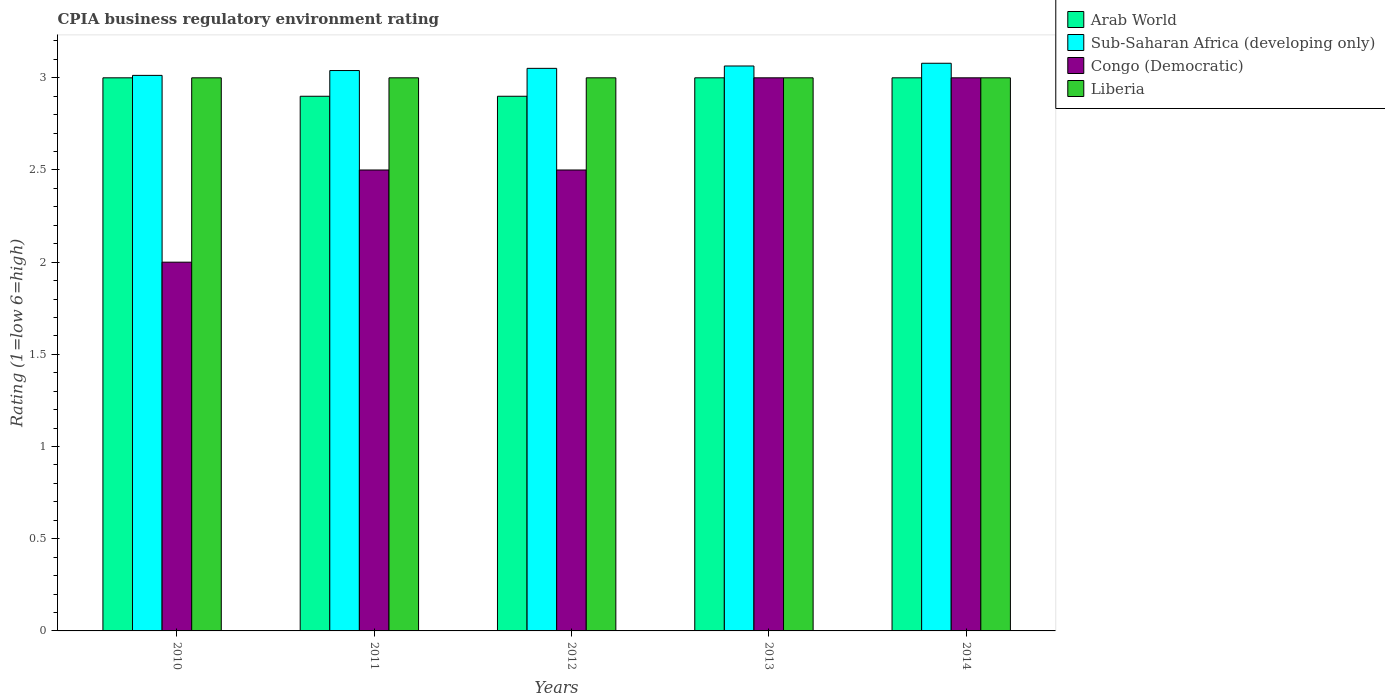How many different coloured bars are there?
Provide a short and direct response. 4. How many groups of bars are there?
Give a very brief answer. 5. What is the label of the 2nd group of bars from the left?
Offer a terse response. 2011. What is the CPIA rating in Sub-Saharan Africa (developing only) in 2010?
Your answer should be compact. 3.01. Across all years, what is the maximum CPIA rating in Liberia?
Keep it short and to the point. 3. In which year was the CPIA rating in Arab World maximum?
Offer a terse response. 2010. What is the average CPIA rating in Arab World per year?
Offer a terse response. 2.96. In the year 2014, what is the difference between the CPIA rating in Arab World and CPIA rating in Sub-Saharan Africa (developing only)?
Your response must be concise. -0.08. What is the difference between the highest and the second highest CPIA rating in Sub-Saharan Africa (developing only)?
Offer a very short reply. 0.01. What is the difference between the highest and the lowest CPIA rating in Sub-Saharan Africa (developing only)?
Make the answer very short. 0.07. In how many years, is the CPIA rating in Sub-Saharan Africa (developing only) greater than the average CPIA rating in Sub-Saharan Africa (developing only) taken over all years?
Keep it short and to the point. 3. Is the sum of the CPIA rating in Liberia in 2010 and 2011 greater than the maximum CPIA rating in Congo (Democratic) across all years?
Provide a succinct answer. Yes. What does the 2nd bar from the left in 2014 represents?
Your answer should be compact. Sub-Saharan Africa (developing only). What does the 4th bar from the right in 2011 represents?
Give a very brief answer. Arab World. Are all the bars in the graph horizontal?
Keep it short and to the point. No. How many years are there in the graph?
Your answer should be compact. 5. What is the difference between two consecutive major ticks on the Y-axis?
Keep it short and to the point. 0.5. Are the values on the major ticks of Y-axis written in scientific E-notation?
Provide a succinct answer. No. Where does the legend appear in the graph?
Provide a succinct answer. Top right. What is the title of the graph?
Your response must be concise. CPIA business regulatory environment rating. Does "Botswana" appear as one of the legend labels in the graph?
Your answer should be very brief. No. What is the label or title of the Y-axis?
Offer a very short reply. Rating (1=low 6=high). What is the Rating (1=low 6=high) of Arab World in 2010?
Ensure brevity in your answer.  3. What is the Rating (1=low 6=high) in Sub-Saharan Africa (developing only) in 2010?
Provide a short and direct response. 3.01. What is the Rating (1=low 6=high) of Liberia in 2010?
Provide a short and direct response. 3. What is the Rating (1=low 6=high) in Sub-Saharan Africa (developing only) in 2011?
Give a very brief answer. 3.04. What is the Rating (1=low 6=high) in Sub-Saharan Africa (developing only) in 2012?
Your answer should be very brief. 3.05. What is the Rating (1=low 6=high) in Congo (Democratic) in 2012?
Give a very brief answer. 2.5. What is the Rating (1=low 6=high) in Arab World in 2013?
Offer a terse response. 3. What is the Rating (1=low 6=high) of Sub-Saharan Africa (developing only) in 2013?
Offer a terse response. 3.06. What is the Rating (1=low 6=high) in Congo (Democratic) in 2013?
Keep it short and to the point. 3. What is the Rating (1=low 6=high) of Liberia in 2013?
Your answer should be compact. 3. What is the Rating (1=low 6=high) in Arab World in 2014?
Your answer should be very brief. 3. What is the Rating (1=low 6=high) in Sub-Saharan Africa (developing only) in 2014?
Your answer should be compact. 3.08. What is the Rating (1=low 6=high) in Liberia in 2014?
Your response must be concise. 3. Across all years, what is the maximum Rating (1=low 6=high) of Sub-Saharan Africa (developing only)?
Provide a succinct answer. 3.08. Across all years, what is the maximum Rating (1=low 6=high) of Congo (Democratic)?
Provide a succinct answer. 3. Across all years, what is the maximum Rating (1=low 6=high) of Liberia?
Keep it short and to the point. 3. Across all years, what is the minimum Rating (1=low 6=high) in Arab World?
Provide a succinct answer. 2.9. Across all years, what is the minimum Rating (1=low 6=high) of Sub-Saharan Africa (developing only)?
Provide a short and direct response. 3.01. Across all years, what is the minimum Rating (1=low 6=high) of Congo (Democratic)?
Give a very brief answer. 2. Across all years, what is the minimum Rating (1=low 6=high) of Liberia?
Keep it short and to the point. 3. What is the total Rating (1=low 6=high) of Arab World in the graph?
Offer a terse response. 14.8. What is the total Rating (1=low 6=high) in Sub-Saharan Africa (developing only) in the graph?
Ensure brevity in your answer.  15.25. What is the difference between the Rating (1=low 6=high) of Sub-Saharan Africa (developing only) in 2010 and that in 2011?
Your answer should be compact. -0.03. What is the difference between the Rating (1=low 6=high) of Liberia in 2010 and that in 2011?
Make the answer very short. 0. What is the difference between the Rating (1=low 6=high) of Arab World in 2010 and that in 2012?
Offer a very short reply. 0.1. What is the difference between the Rating (1=low 6=high) in Sub-Saharan Africa (developing only) in 2010 and that in 2012?
Keep it short and to the point. -0.04. What is the difference between the Rating (1=low 6=high) in Liberia in 2010 and that in 2012?
Ensure brevity in your answer.  0. What is the difference between the Rating (1=low 6=high) of Arab World in 2010 and that in 2013?
Offer a very short reply. 0. What is the difference between the Rating (1=low 6=high) in Sub-Saharan Africa (developing only) in 2010 and that in 2013?
Ensure brevity in your answer.  -0.05. What is the difference between the Rating (1=low 6=high) of Congo (Democratic) in 2010 and that in 2013?
Your response must be concise. -1. What is the difference between the Rating (1=low 6=high) of Liberia in 2010 and that in 2013?
Offer a terse response. 0. What is the difference between the Rating (1=low 6=high) in Arab World in 2010 and that in 2014?
Make the answer very short. 0. What is the difference between the Rating (1=low 6=high) in Sub-Saharan Africa (developing only) in 2010 and that in 2014?
Make the answer very short. -0.07. What is the difference between the Rating (1=low 6=high) in Liberia in 2010 and that in 2014?
Ensure brevity in your answer.  0. What is the difference between the Rating (1=low 6=high) of Sub-Saharan Africa (developing only) in 2011 and that in 2012?
Make the answer very short. -0.01. What is the difference between the Rating (1=low 6=high) of Congo (Democratic) in 2011 and that in 2012?
Your answer should be very brief. 0. What is the difference between the Rating (1=low 6=high) of Arab World in 2011 and that in 2013?
Provide a short and direct response. -0.1. What is the difference between the Rating (1=low 6=high) in Sub-Saharan Africa (developing only) in 2011 and that in 2013?
Your answer should be compact. -0.02. What is the difference between the Rating (1=low 6=high) in Arab World in 2011 and that in 2014?
Keep it short and to the point. -0.1. What is the difference between the Rating (1=low 6=high) in Sub-Saharan Africa (developing only) in 2011 and that in 2014?
Offer a very short reply. -0.04. What is the difference between the Rating (1=low 6=high) in Liberia in 2011 and that in 2014?
Make the answer very short. 0. What is the difference between the Rating (1=low 6=high) of Arab World in 2012 and that in 2013?
Your answer should be compact. -0.1. What is the difference between the Rating (1=low 6=high) of Sub-Saharan Africa (developing only) in 2012 and that in 2013?
Provide a succinct answer. -0.01. What is the difference between the Rating (1=low 6=high) of Liberia in 2012 and that in 2013?
Your answer should be compact. 0. What is the difference between the Rating (1=low 6=high) in Sub-Saharan Africa (developing only) in 2012 and that in 2014?
Give a very brief answer. -0.03. What is the difference between the Rating (1=low 6=high) in Liberia in 2012 and that in 2014?
Make the answer very short. 0. What is the difference between the Rating (1=low 6=high) in Sub-Saharan Africa (developing only) in 2013 and that in 2014?
Keep it short and to the point. -0.01. What is the difference between the Rating (1=low 6=high) in Arab World in 2010 and the Rating (1=low 6=high) in Sub-Saharan Africa (developing only) in 2011?
Provide a short and direct response. -0.04. What is the difference between the Rating (1=low 6=high) in Sub-Saharan Africa (developing only) in 2010 and the Rating (1=low 6=high) in Congo (Democratic) in 2011?
Give a very brief answer. 0.51. What is the difference between the Rating (1=low 6=high) of Sub-Saharan Africa (developing only) in 2010 and the Rating (1=low 6=high) of Liberia in 2011?
Keep it short and to the point. 0.01. What is the difference between the Rating (1=low 6=high) in Arab World in 2010 and the Rating (1=low 6=high) in Sub-Saharan Africa (developing only) in 2012?
Offer a very short reply. -0.05. What is the difference between the Rating (1=low 6=high) in Arab World in 2010 and the Rating (1=low 6=high) in Congo (Democratic) in 2012?
Provide a short and direct response. 0.5. What is the difference between the Rating (1=low 6=high) in Sub-Saharan Africa (developing only) in 2010 and the Rating (1=low 6=high) in Congo (Democratic) in 2012?
Provide a succinct answer. 0.51. What is the difference between the Rating (1=low 6=high) of Sub-Saharan Africa (developing only) in 2010 and the Rating (1=low 6=high) of Liberia in 2012?
Give a very brief answer. 0.01. What is the difference between the Rating (1=low 6=high) of Arab World in 2010 and the Rating (1=low 6=high) of Sub-Saharan Africa (developing only) in 2013?
Your answer should be compact. -0.06. What is the difference between the Rating (1=low 6=high) of Arab World in 2010 and the Rating (1=low 6=high) of Congo (Democratic) in 2013?
Your response must be concise. 0. What is the difference between the Rating (1=low 6=high) in Arab World in 2010 and the Rating (1=low 6=high) in Liberia in 2013?
Your answer should be very brief. 0. What is the difference between the Rating (1=low 6=high) of Sub-Saharan Africa (developing only) in 2010 and the Rating (1=low 6=high) of Congo (Democratic) in 2013?
Provide a short and direct response. 0.01. What is the difference between the Rating (1=low 6=high) in Sub-Saharan Africa (developing only) in 2010 and the Rating (1=low 6=high) in Liberia in 2013?
Give a very brief answer. 0.01. What is the difference between the Rating (1=low 6=high) of Congo (Democratic) in 2010 and the Rating (1=low 6=high) of Liberia in 2013?
Your response must be concise. -1. What is the difference between the Rating (1=low 6=high) of Arab World in 2010 and the Rating (1=low 6=high) of Sub-Saharan Africa (developing only) in 2014?
Offer a terse response. -0.08. What is the difference between the Rating (1=low 6=high) of Arab World in 2010 and the Rating (1=low 6=high) of Congo (Democratic) in 2014?
Keep it short and to the point. 0. What is the difference between the Rating (1=low 6=high) of Arab World in 2010 and the Rating (1=low 6=high) of Liberia in 2014?
Your answer should be compact. 0. What is the difference between the Rating (1=low 6=high) of Sub-Saharan Africa (developing only) in 2010 and the Rating (1=low 6=high) of Congo (Democratic) in 2014?
Provide a succinct answer. 0.01. What is the difference between the Rating (1=low 6=high) in Sub-Saharan Africa (developing only) in 2010 and the Rating (1=low 6=high) in Liberia in 2014?
Keep it short and to the point. 0.01. What is the difference between the Rating (1=low 6=high) of Arab World in 2011 and the Rating (1=low 6=high) of Sub-Saharan Africa (developing only) in 2012?
Ensure brevity in your answer.  -0.15. What is the difference between the Rating (1=low 6=high) in Arab World in 2011 and the Rating (1=low 6=high) in Liberia in 2012?
Offer a terse response. -0.1. What is the difference between the Rating (1=low 6=high) in Sub-Saharan Africa (developing only) in 2011 and the Rating (1=low 6=high) in Congo (Democratic) in 2012?
Keep it short and to the point. 0.54. What is the difference between the Rating (1=low 6=high) in Sub-Saharan Africa (developing only) in 2011 and the Rating (1=low 6=high) in Liberia in 2012?
Offer a terse response. 0.04. What is the difference between the Rating (1=low 6=high) in Arab World in 2011 and the Rating (1=low 6=high) in Sub-Saharan Africa (developing only) in 2013?
Ensure brevity in your answer.  -0.16. What is the difference between the Rating (1=low 6=high) in Arab World in 2011 and the Rating (1=low 6=high) in Congo (Democratic) in 2013?
Provide a succinct answer. -0.1. What is the difference between the Rating (1=low 6=high) of Sub-Saharan Africa (developing only) in 2011 and the Rating (1=low 6=high) of Congo (Democratic) in 2013?
Give a very brief answer. 0.04. What is the difference between the Rating (1=low 6=high) in Sub-Saharan Africa (developing only) in 2011 and the Rating (1=low 6=high) in Liberia in 2013?
Offer a very short reply. 0.04. What is the difference between the Rating (1=low 6=high) in Congo (Democratic) in 2011 and the Rating (1=low 6=high) in Liberia in 2013?
Your answer should be very brief. -0.5. What is the difference between the Rating (1=low 6=high) in Arab World in 2011 and the Rating (1=low 6=high) in Sub-Saharan Africa (developing only) in 2014?
Keep it short and to the point. -0.18. What is the difference between the Rating (1=low 6=high) in Sub-Saharan Africa (developing only) in 2011 and the Rating (1=low 6=high) in Congo (Democratic) in 2014?
Give a very brief answer. 0.04. What is the difference between the Rating (1=low 6=high) in Sub-Saharan Africa (developing only) in 2011 and the Rating (1=low 6=high) in Liberia in 2014?
Your response must be concise. 0.04. What is the difference between the Rating (1=low 6=high) of Congo (Democratic) in 2011 and the Rating (1=low 6=high) of Liberia in 2014?
Offer a terse response. -0.5. What is the difference between the Rating (1=low 6=high) in Arab World in 2012 and the Rating (1=low 6=high) in Sub-Saharan Africa (developing only) in 2013?
Your response must be concise. -0.16. What is the difference between the Rating (1=low 6=high) of Arab World in 2012 and the Rating (1=low 6=high) of Congo (Democratic) in 2013?
Offer a terse response. -0.1. What is the difference between the Rating (1=low 6=high) of Arab World in 2012 and the Rating (1=low 6=high) of Liberia in 2013?
Make the answer very short. -0.1. What is the difference between the Rating (1=low 6=high) of Sub-Saharan Africa (developing only) in 2012 and the Rating (1=low 6=high) of Congo (Democratic) in 2013?
Your answer should be compact. 0.05. What is the difference between the Rating (1=low 6=high) of Sub-Saharan Africa (developing only) in 2012 and the Rating (1=low 6=high) of Liberia in 2013?
Your response must be concise. 0.05. What is the difference between the Rating (1=low 6=high) in Congo (Democratic) in 2012 and the Rating (1=low 6=high) in Liberia in 2013?
Ensure brevity in your answer.  -0.5. What is the difference between the Rating (1=low 6=high) in Arab World in 2012 and the Rating (1=low 6=high) in Sub-Saharan Africa (developing only) in 2014?
Your answer should be compact. -0.18. What is the difference between the Rating (1=low 6=high) in Arab World in 2012 and the Rating (1=low 6=high) in Liberia in 2014?
Your response must be concise. -0.1. What is the difference between the Rating (1=low 6=high) in Sub-Saharan Africa (developing only) in 2012 and the Rating (1=low 6=high) in Congo (Democratic) in 2014?
Make the answer very short. 0.05. What is the difference between the Rating (1=low 6=high) of Sub-Saharan Africa (developing only) in 2012 and the Rating (1=low 6=high) of Liberia in 2014?
Offer a very short reply. 0.05. What is the difference between the Rating (1=low 6=high) of Arab World in 2013 and the Rating (1=low 6=high) of Sub-Saharan Africa (developing only) in 2014?
Your answer should be compact. -0.08. What is the difference between the Rating (1=low 6=high) of Arab World in 2013 and the Rating (1=low 6=high) of Congo (Democratic) in 2014?
Provide a succinct answer. 0. What is the difference between the Rating (1=low 6=high) of Sub-Saharan Africa (developing only) in 2013 and the Rating (1=low 6=high) of Congo (Democratic) in 2014?
Your answer should be compact. 0.06. What is the difference between the Rating (1=low 6=high) of Sub-Saharan Africa (developing only) in 2013 and the Rating (1=low 6=high) of Liberia in 2014?
Your answer should be compact. 0.06. What is the average Rating (1=low 6=high) of Arab World per year?
Your answer should be very brief. 2.96. What is the average Rating (1=low 6=high) in Sub-Saharan Africa (developing only) per year?
Provide a succinct answer. 3.05. What is the average Rating (1=low 6=high) in Liberia per year?
Your answer should be compact. 3. In the year 2010, what is the difference between the Rating (1=low 6=high) in Arab World and Rating (1=low 6=high) in Sub-Saharan Africa (developing only)?
Offer a very short reply. -0.01. In the year 2010, what is the difference between the Rating (1=low 6=high) of Sub-Saharan Africa (developing only) and Rating (1=low 6=high) of Congo (Democratic)?
Provide a succinct answer. 1.01. In the year 2010, what is the difference between the Rating (1=low 6=high) of Sub-Saharan Africa (developing only) and Rating (1=low 6=high) of Liberia?
Give a very brief answer. 0.01. In the year 2010, what is the difference between the Rating (1=low 6=high) of Congo (Democratic) and Rating (1=low 6=high) of Liberia?
Offer a very short reply. -1. In the year 2011, what is the difference between the Rating (1=low 6=high) in Arab World and Rating (1=low 6=high) in Sub-Saharan Africa (developing only)?
Provide a short and direct response. -0.14. In the year 2011, what is the difference between the Rating (1=low 6=high) of Sub-Saharan Africa (developing only) and Rating (1=low 6=high) of Congo (Democratic)?
Your answer should be very brief. 0.54. In the year 2011, what is the difference between the Rating (1=low 6=high) of Sub-Saharan Africa (developing only) and Rating (1=low 6=high) of Liberia?
Ensure brevity in your answer.  0.04. In the year 2012, what is the difference between the Rating (1=low 6=high) of Arab World and Rating (1=low 6=high) of Sub-Saharan Africa (developing only)?
Your response must be concise. -0.15. In the year 2012, what is the difference between the Rating (1=low 6=high) of Arab World and Rating (1=low 6=high) of Congo (Democratic)?
Make the answer very short. 0.4. In the year 2012, what is the difference between the Rating (1=low 6=high) in Sub-Saharan Africa (developing only) and Rating (1=low 6=high) in Congo (Democratic)?
Your response must be concise. 0.55. In the year 2012, what is the difference between the Rating (1=low 6=high) of Sub-Saharan Africa (developing only) and Rating (1=low 6=high) of Liberia?
Your answer should be compact. 0.05. In the year 2013, what is the difference between the Rating (1=low 6=high) in Arab World and Rating (1=low 6=high) in Sub-Saharan Africa (developing only)?
Your answer should be very brief. -0.06. In the year 2013, what is the difference between the Rating (1=low 6=high) of Arab World and Rating (1=low 6=high) of Liberia?
Offer a terse response. 0. In the year 2013, what is the difference between the Rating (1=low 6=high) of Sub-Saharan Africa (developing only) and Rating (1=low 6=high) of Congo (Democratic)?
Ensure brevity in your answer.  0.06. In the year 2013, what is the difference between the Rating (1=low 6=high) in Sub-Saharan Africa (developing only) and Rating (1=low 6=high) in Liberia?
Your answer should be very brief. 0.06. In the year 2013, what is the difference between the Rating (1=low 6=high) in Congo (Democratic) and Rating (1=low 6=high) in Liberia?
Your answer should be compact. 0. In the year 2014, what is the difference between the Rating (1=low 6=high) in Arab World and Rating (1=low 6=high) in Sub-Saharan Africa (developing only)?
Offer a terse response. -0.08. In the year 2014, what is the difference between the Rating (1=low 6=high) of Arab World and Rating (1=low 6=high) of Liberia?
Offer a very short reply. 0. In the year 2014, what is the difference between the Rating (1=low 6=high) in Sub-Saharan Africa (developing only) and Rating (1=low 6=high) in Congo (Democratic)?
Offer a terse response. 0.08. In the year 2014, what is the difference between the Rating (1=low 6=high) in Sub-Saharan Africa (developing only) and Rating (1=low 6=high) in Liberia?
Provide a short and direct response. 0.08. In the year 2014, what is the difference between the Rating (1=low 6=high) of Congo (Democratic) and Rating (1=low 6=high) of Liberia?
Ensure brevity in your answer.  0. What is the ratio of the Rating (1=low 6=high) of Arab World in 2010 to that in 2011?
Provide a succinct answer. 1.03. What is the ratio of the Rating (1=low 6=high) of Congo (Democratic) in 2010 to that in 2011?
Your answer should be very brief. 0.8. What is the ratio of the Rating (1=low 6=high) of Liberia in 2010 to that in 2011?
Your answer should be compact. 1. What is the ratio of the Rating (1=low 6=high) of Arab World in 2010 to that in 2012?
Your answer should be very brief. 1.03. What is the ratio of the Rating (1=low 6=high) of Sub-Saharan Africa (developing only) in 2010 to that in 2012?
Give a very brief answer. 0.99. What is the ratio of the Rating (1=low 6=high) of Congo (Democratic) in 2010 to that in 2012?
Offer a very short reply. 0.8. What is the ratio of the Rating (1=low 6=high) in Arab World in 2010 to that in 2013?
Make the answer very short. 1. What is the ratio of the Rating (1=low 6=high) in Sub-Saharan Africa (developing only) in 2010 to that in 2013?
Your answer should be very brief. 0.98. What is the ratio of the Rating (1=low 6=high) in Congo (Democratic) in 2010 to that in 2013?
Keep it short and to the point. 0.67. What is the ratio of the Rating (1=low 6=high) of Arab World in 2010 to that in 2014?
Provide a short and direct response. 1. What is the ratio of the Rating (1=low 6=high) of Sub-Saharan Africa (developing only) in 2010 to that in 2014?
Offer a very short reply. 0.98. What is the ratio of the Rating (1=low 6=high) in Sub-Saharan Africa (developing only) in 2011 to that in 2012?
Keep it short and to the point. 1. What is the ratio of the Rating (1=low 6=high) of Congo (Democratic) in 2011 to that in 2012?
Keep it short and to the point. 1. What is the ratio of the Rating (1=low 6=high) of Arab World in 2011 to that in 2013?
Offer a very short reply. 0.97. What is the ratio of the Rating (1=low 6=high) in Liberia in 2011 to that in 2013?
Your response must be concise. 1. What is the ratio of the Rating (1=low 6=high) of Arab World in 2011 to that in 2014?
Offer a terse response. 0.97. What is the ratio of the Rating (1=low 6=high) of Sub-Saharan Africa (developing only) in 2011 to that in 2014?
Ensure brevity in your answer.  0.99. What is the ratio of the Rating (1=low 6=high) in Liberia in 2011 to that in 2014?
Your answer should be very brief. 1. What is the ratio of the Rating (1=low 6=high) in Arab World in 2012 to that in 2013?
Provide a succinct answer. 0.97. What is the ratio of the Rating (1=low 6=high) in Sub-Saharan Africa (developing only) in 2012 to that in 2013?
Your response must be concise. 1. What is the ratio of the Rating (1=low 6=high) of Arab World in 2012 to that in 2014?
Make the answer very short. 0.97. What is the ratio of the Rating (1=low 6=high) of Congo (Democratic) in 2012 to that in 2014?
Give a very brief answer. 0.83. What is the ratio of the Rating (1=low 6=high) of Liberia in 2012 to that in 2014?
Keep it short and to the point. 1. What is the ratio of the Rating (1=low 6=high) of Congo (Democratic) in 2013 to that in 2014?
Your answer should be compact. 1. What is the difference between the highest and the second highest Rating (1=low 6=high) in Sub-Saharan Africa (developing only)?
Offer a terse response. 0.01. What is the difference between the highest and the lowest Rating (1=low 6=high) in Arab World?
Give a very brief answer. 0.1. What is the difference between the highest and the lowest Rating (1=low 6=high) in Sub-Saharan Africa (developing only)?
Provide a short and direct response. 0.07. What is the difference between the highest and the lowest Rating (1=low 6=high) in Liberia?
Provide a short and direct response. 0. 